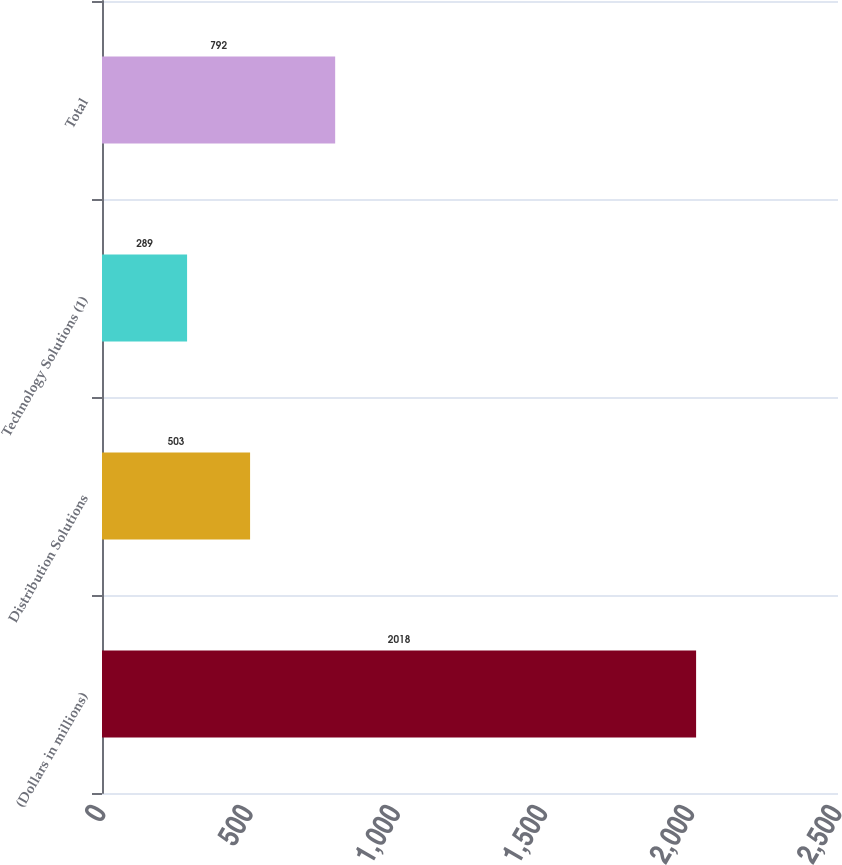Convert chart to OTSL. <chart><loc_0><loc_0><loc_500><loc_500><bar_chart><fcel>(Dollars in millions)<fcel>Distribution Solutions<fcel>Technology Solutions (1)<fcel>Total<nl><fcel>2018<fcel>503<fcel>289<fcel>792<nl></chart> 